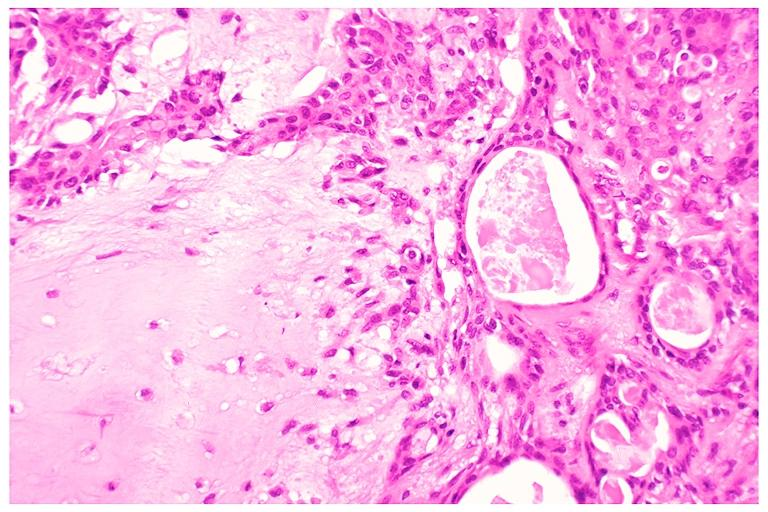does metastatic malignant melanoma show pleomorphic adenoma benign mixed tumor?
Answer the question using a single word or phrase. No 